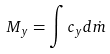Convert formula to latex. <formula><loc_0><loc_0><loc_500><loc_500>M _ { y } = \int c _ { y } d \dot { m }</formula> 